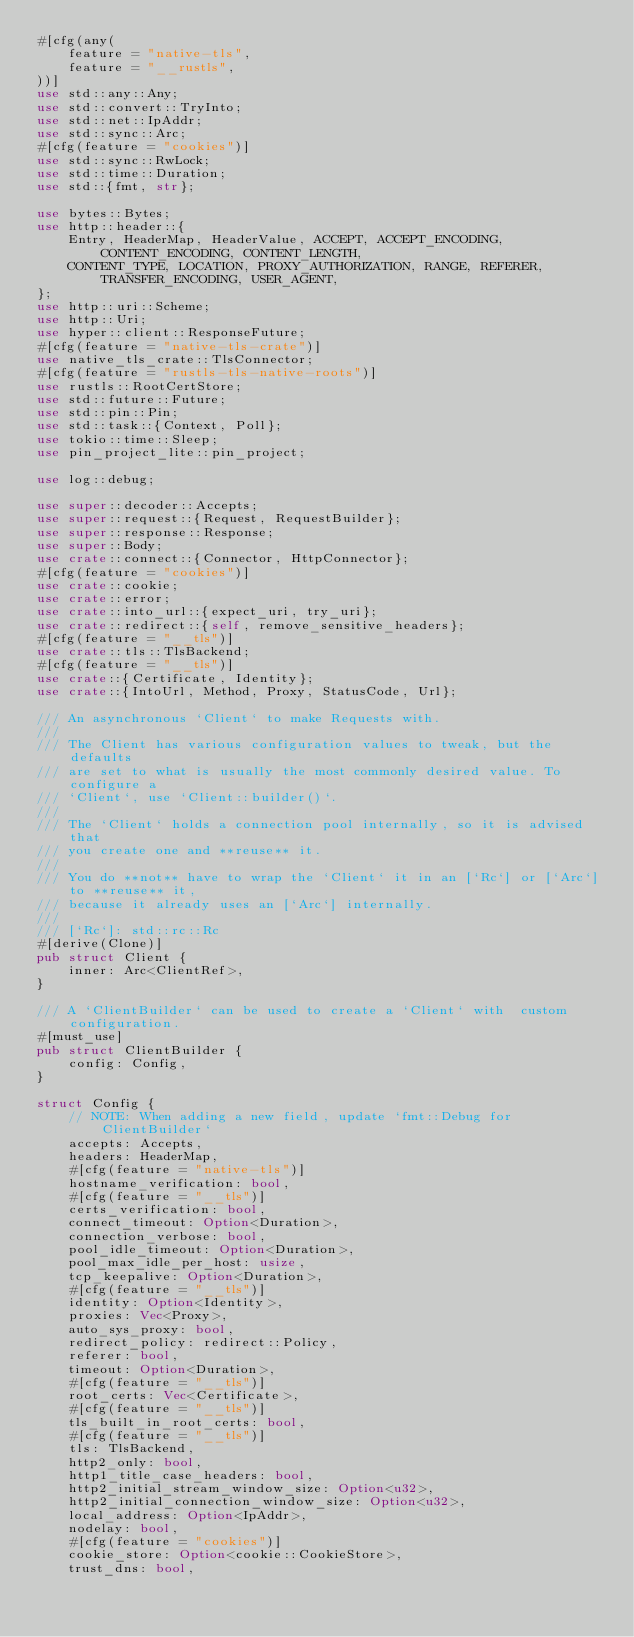Convert code to text. <code><loc_0><loc_0><loc_500><loc_500><_Rust_>#[cfg(any(
    feature = "native-tls",
    feature = "__rustls",
))]
use std::any::Any;
use std::convert::TryInto;
use std::net::IpAddr;
use std::sync::Arc;
#[cfg(feature = "cookies")]
use std::sync::RwLock;
use std::time::Duration;
use std::{fmt, str};

use bytes::Bytes;
use http::header::{
    Entry, HeaderMap, HeaderValue, ACCEPT, ACCEPT_ENCODING, CONTENT_ENCODING, CONTENT_LENGTH,
    CONTENT_TYPE, LOCATION, PROXY_AUTHORIZATION, RANGE, REFERER, TRANSFER_ENCODING, USER_AGENT,
};
use http::uri::Scheme;
use http::Uri;
use hyper::client::ResponseFuture;
#[cfg(feature = "native-tls-crate")]
use native_tls_crate::TlsConnector;
#[cfg(feature = "rustls-tls-native-roots")]
use rustls::RootCertStore;
use std::future::Future;
use std::pin::Pin;
use std::task::{Context, Poll};
use tokio::time::Sleep;
use pin_project_lite::pin_project;

use log::debug;

use super::decoder::Accepts;
use super::request::{Request, RequestBuilder};
use super::response::Response;
use super::Body;
use crate::connect::{Connector, HttpConnector};
#[cfg(feature = "cookies")]
use crate::cookie;
use crate::error;
use crate::into_url::{expect_uri, try_uri};
use crate::redirect::{self, remove_sensitive_headers};
#[cfg(feature = "__tls")]
use crate::tls::TlsBackend;
#[cfg(feature = "__tls")]
use crate::{Certificate, Identity};
use crate::{IntoUrl, Method, Proxy, StatusCode, Url};

/// An asynchronous `Client` to make Requests with.
///
/// The Client has various configuration values to tweak, but the defaults
/// are set to what is usually the most commonly desired value. To configure a
/// `Client`, use `Client::builder()`.
///
/// The `Client` holds a connection pool internally, so it is advised that
/// you create one and **reuse** it.
///
/// You do **not** have to wrap the `Client` it in an [`Rc`] or [`Arc`] to **reuse** it,
/// because it already uses an [`Arc`] internally.
///
/// [`Rc`]: std::rc::Rc
#[derive(Clone)]
pub struct Client {
    inner: Arc<ClientRef>,
}

/// A `ClientBuilder` can be used to create a `Client` with  custom configuration.
#[must_use]
pub struct ClientBuilder {
    config: Config,
}

struct Config {
    // NOTE: When adding a new field, update `fmt::Debug for ClientBuilder`
    accepts: Accepts,
    headers: HeaderMap,
    #[cfg(feature = "native-tls")]
    hostname_verification: bool,
    #[cfg(feature = "__tls")]
    certs_verification: bool,
    connect_timeout: Option<Duration>,
    connection_verbose: bool,
    pool_idle_timeout: Option<Duration>,
    pool_max_idle_per_host: usize,
    tcp_keepalive: Option<Duration>,
    #[cfg(feature = "__tls")]
    identity: Option<Identity>,
    proxies: Vec<Proxy>,
    auto_sys_proxy: bool,
    redirect_policy: redirect::Policy,
    referer: bool,
    timeout: Option<Duration>,
    #[cfg(feature = "__tls")]
    root_certs: Vec<Certificate>,
    #[cfg(feature = "__tls")]
    tls_built_in_root_certs: bool,
    #[cfg(feature = "__tls")]
    tls: TlsBackend,
    http2_only: bool,
    http1_title_case_headers: bool,
    http2_initial_stream_window_size: Option<u32>,
    http2_initial_connection_window_size: Option<u32>,
    local_address: Option<IpAddr>,
    nodelay: bool,
    #[cfg(feature = "cookies")]
    cookie_store: Option<cookie::CookieStore>,
    trust_dns: bool,</code> 